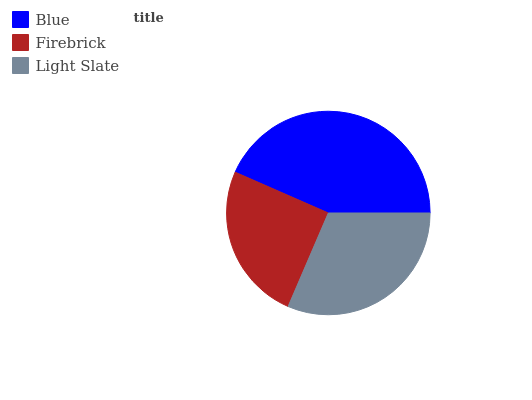Is Firebrick the minimum?
Answer yes or no. Yes. Is Blue the maximum?
Answer yes or no. Yes. Is Light Slate the minimum?
Answer yes or no. No. Is Light Slate the maximum?
Answer yes or no. No. Is Light Slate greater than Firebrick?
Answer yes or no. Yes. Is Firebrick less than Light Slate?
Answer yes or no. Yes. Is Firebrick greater than Light Slate?
Answer yes or no. No. Is Light Slate less than Firebrick?
Answer yes or no. No. Is Light Slate the high median?
Answer yes or no. Yes. Is Light Slate the low median?
Answer yes or no. Yes. Is Blue the high median?
Answer yes or no. No. Is Blue the low median?
Answer yes or no. No. 